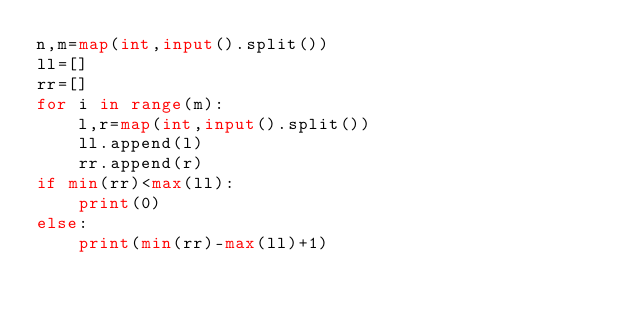Convert code to text. <code><loc_0><loc_0><loc_500><loc_500><_Python_>n,m=map(int,input().split())
ll=[]
rr=[]
for i in range(m):
    l,r=map(int,input().split())
    ll.append(l)
    rr.append(r)
if min(rr)<max(ll):
    print(0)
else:
    print(min(rr)-max(ll)+1)</code> 